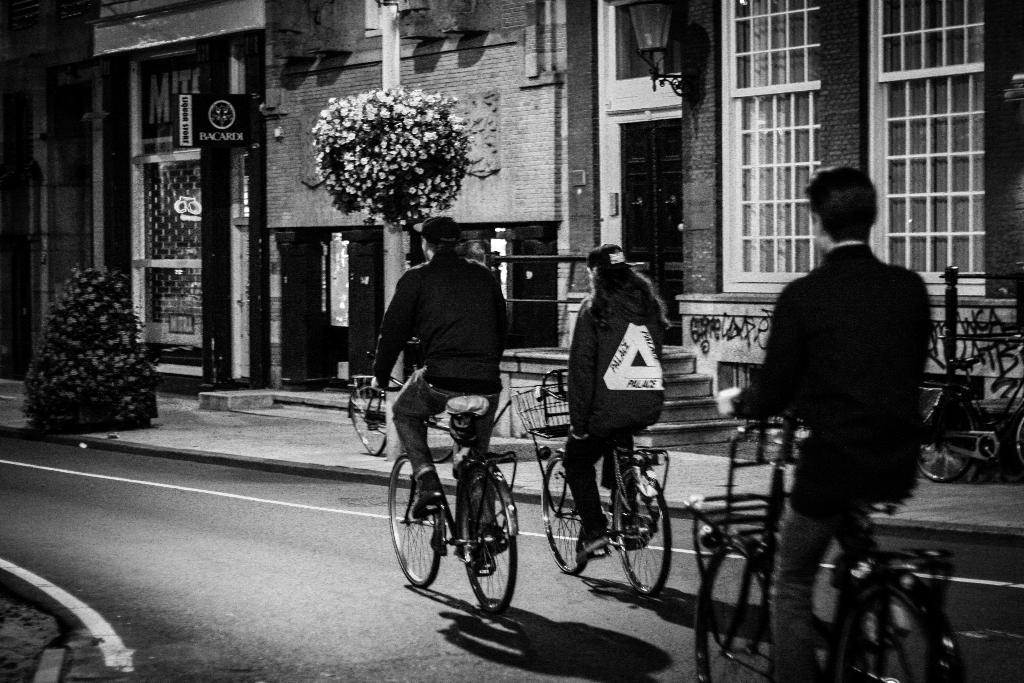Describe this image in one or two sentences. In this picture we can see three persons on the bicycles. This is road and there is a plant. Here we can see a building. And these are the flowers. And this is black and white picture. 